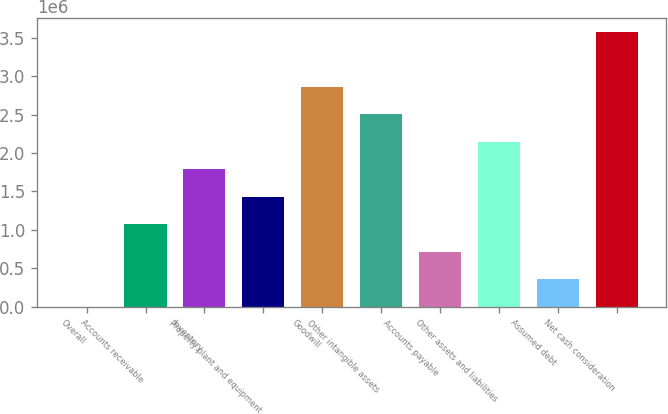<chart> <loc_0><loc_0><loc_500><loc_500><bar_chart><fcel>Overall<fcel>Accounts receivable<fcel>Inventory<fcel>Property plant and equipment<fcel>Goodwill<fcel>Other intangible assets<fcel>Accounts payable<fcel>Other assets and liabilities<fcel>Assumed debt<fcel>Net cash consideration<nl><fcel>2007<fcel>1.07437e+06<fcel>1.78928e+06<fcel>1.43183e+06<fcel>2.86165e+06<fcel>2.5042e+06<fcel>716918<fcel>2.14674e+06<fcel>359462<fcel>3.57656e+06<nl></chart> 